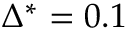<formula> <loc_0><loc_0><loc_500><loc_500>\Delta ^ { * } = 0 . 1</formula> 